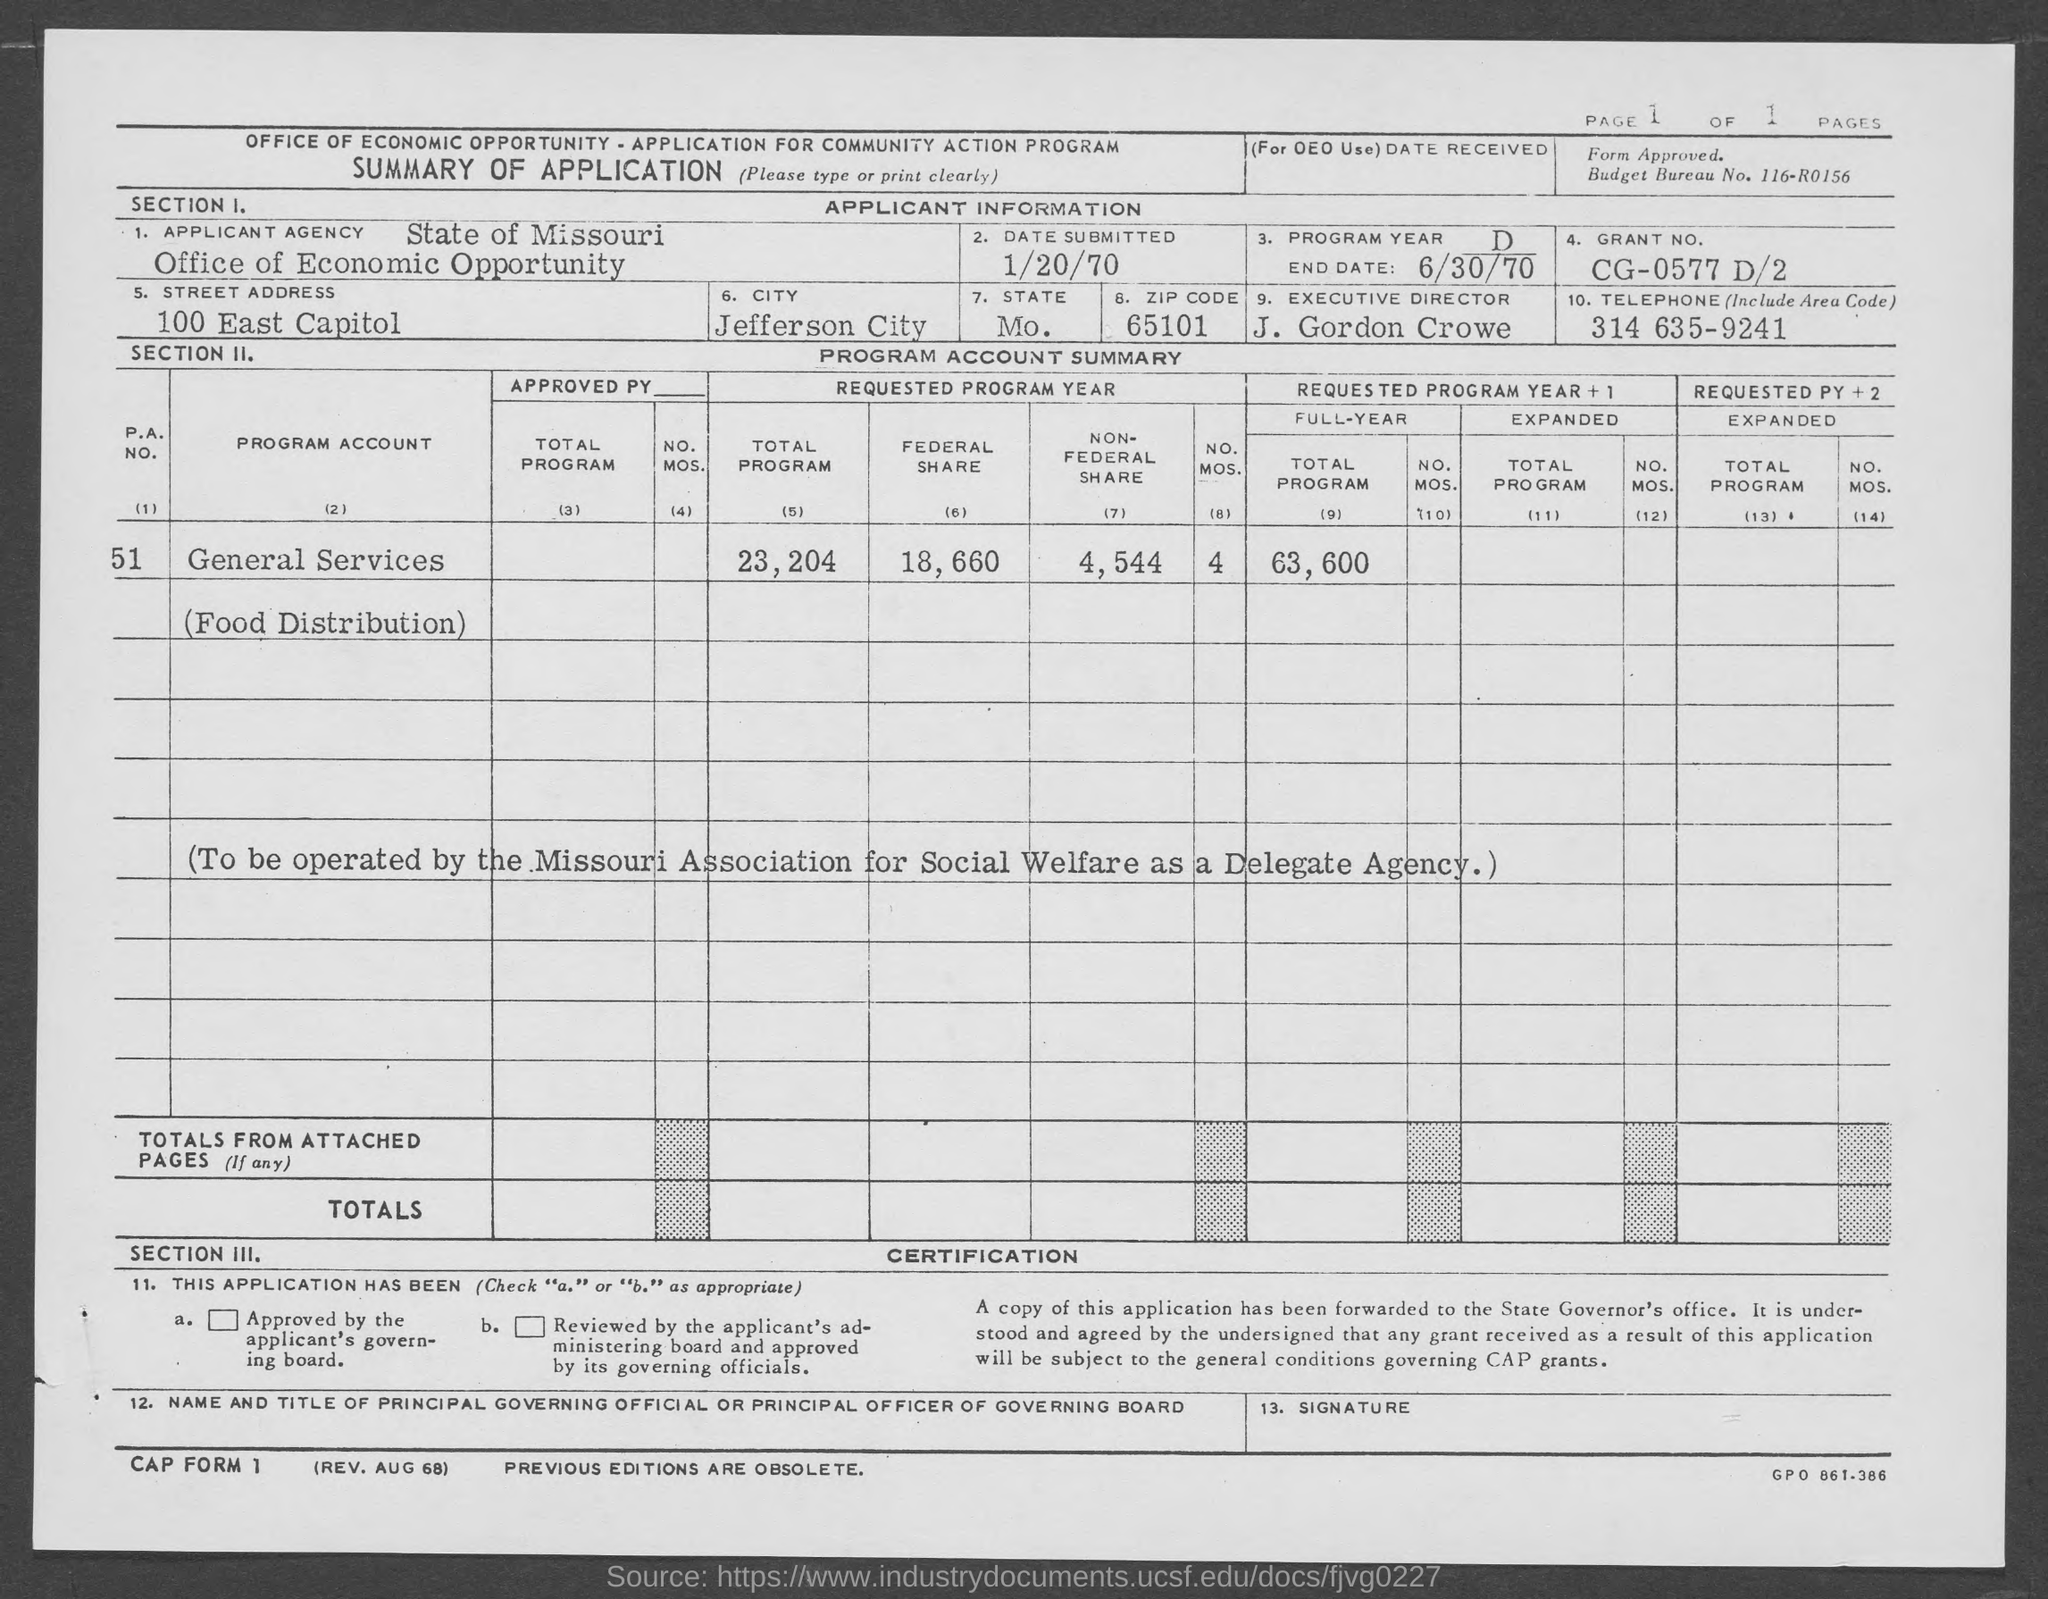What is budget bureau no. ?
Provide a short and direct response. 116-R0156. What is street address of office of economic opportunity?
Your response must be concise. 100 East Capitol. What is the city name ?
Make the answer very short. JEFFERSON CITY. What is the state ?
Provide a succinct answer. MO. What is the grant no.?
Your answer should be very brief. CG-0577 D/2. What is telephone no. (include area code ) ?
Your answer should be compact. 314 635-9241. When is the date submitted ?
Make the answer very short. 1/20/70. 